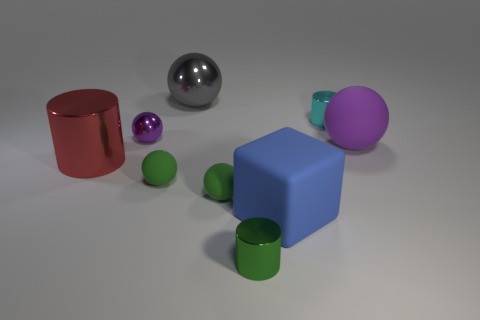Do these objects give any indication of size or scale? The objects in the image do not have a clear point of reference to establish their scale definitively. However, the relative sizes of the objects to each other can be perceived. For instance, the small green spheres are clearly smaller compared to the blue cube and the big red cylinder. What material do you think the objects are made of, based on their appearance? Based on their appearance, the objects seem to have materials that range from matte to highly reflective surfaces. The red cylinder and the blue cube, for example, have a reflective finish that could indicate a metallic or plastic material. The spheres vary, with the metallic one likely being a polished metal and the others potentially being plastic, given their uniform color and less reflective finish. 